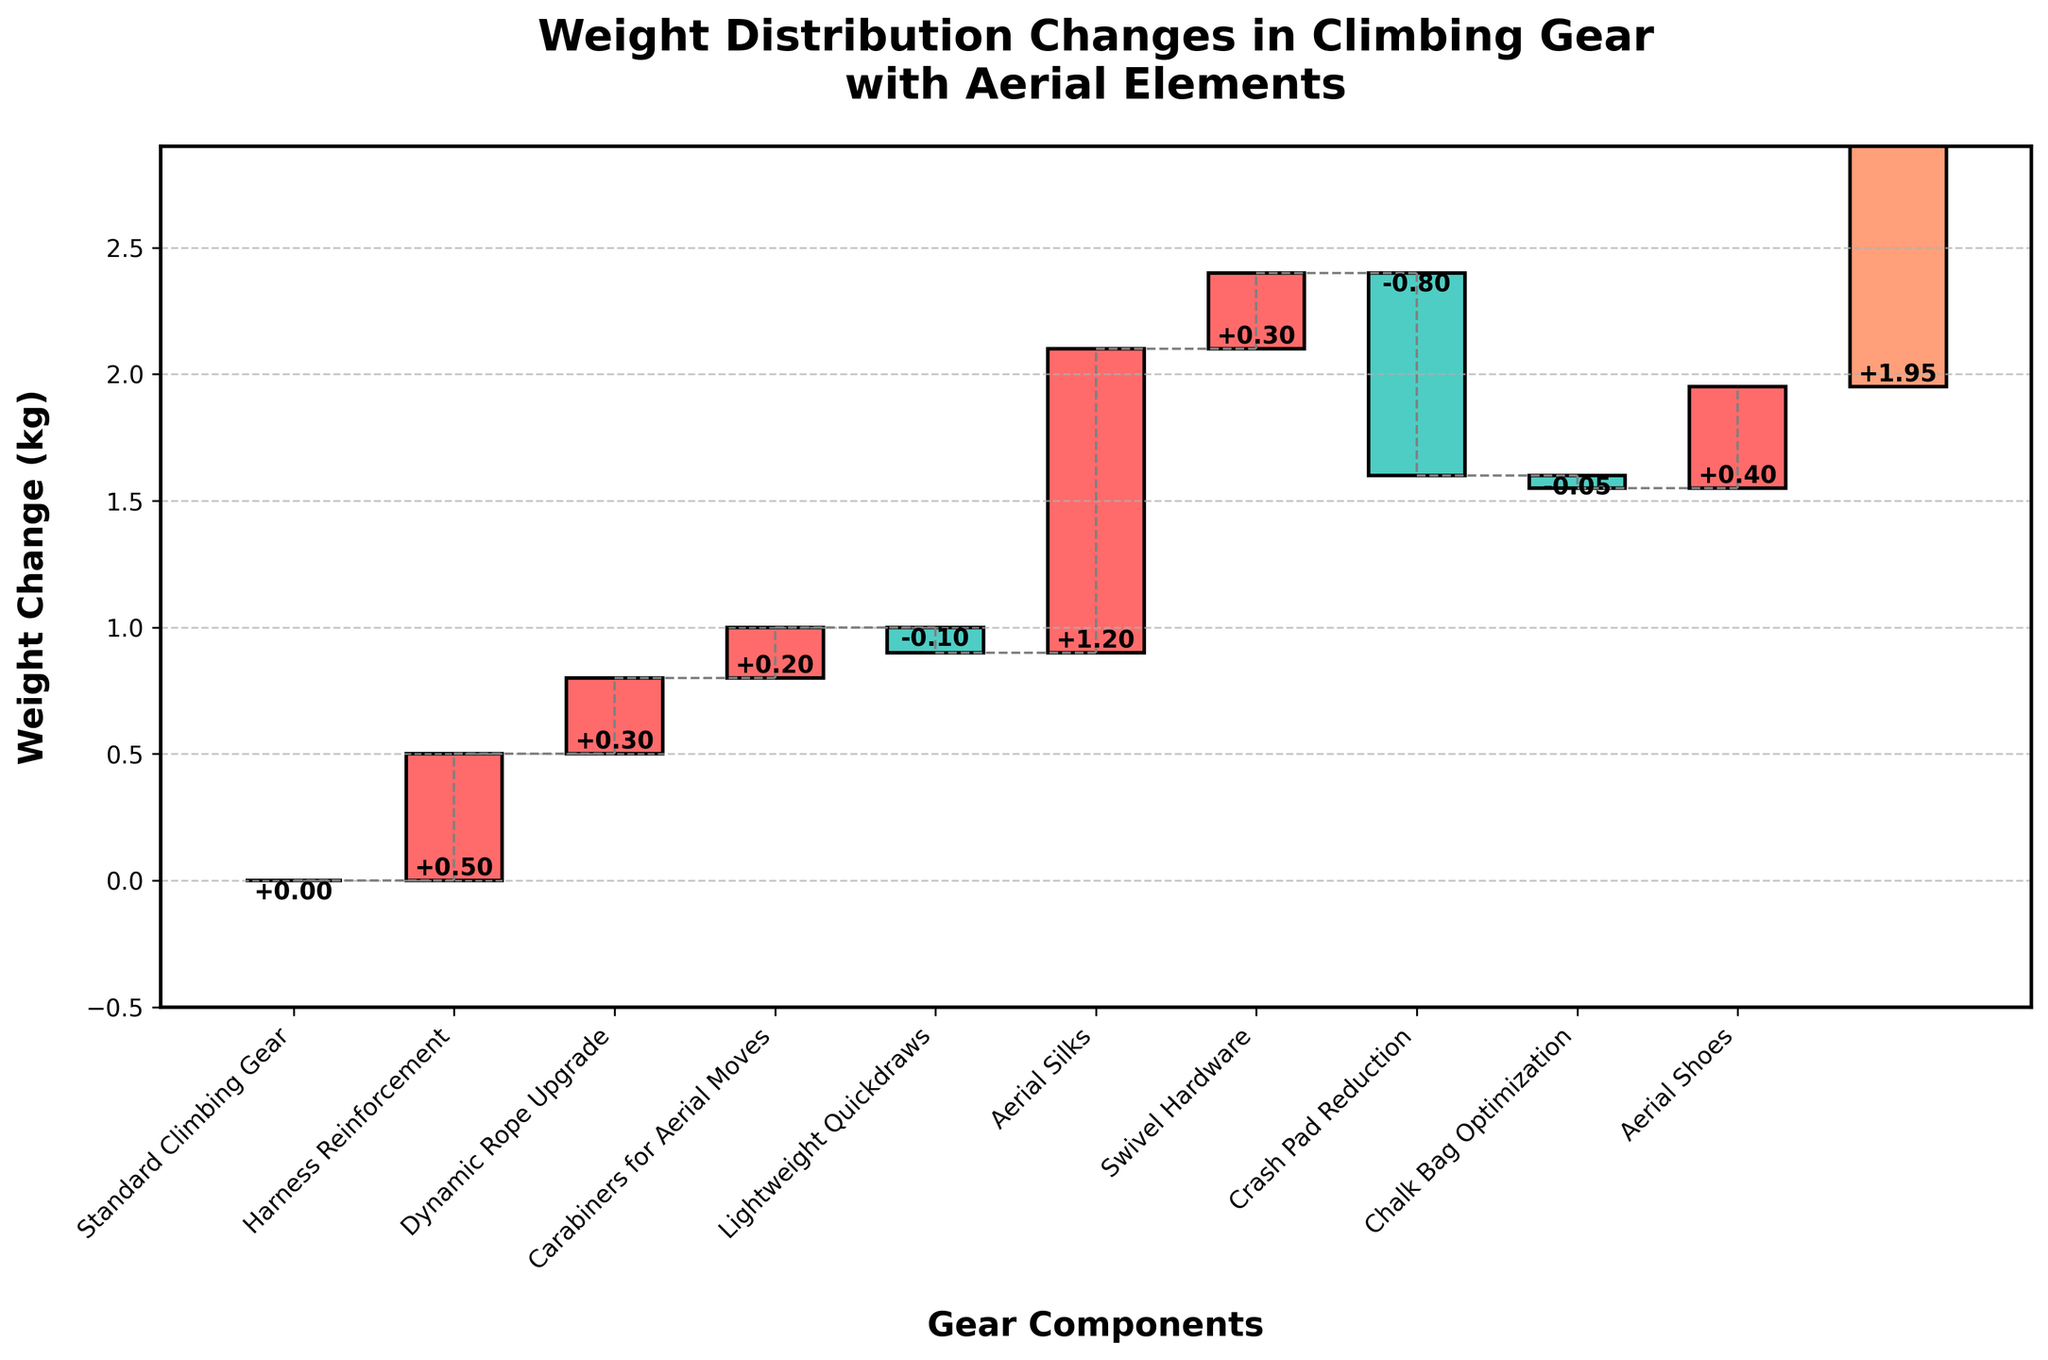what is the title of the chart? The title of the chart is positioned at the top and is styled in bold, larger font for prominence. The title reads "Weight Distribution Changes in Climbing Gear with Aerial Elements".
Answer: Weight Distribution Changes in Climbing Gear with Aerial Elements Which categories contribute to decreasing the total weight? Categories with negative values contribute to weight decrements. In the chart, these are "Lightweight Quickdraws", "Crash Pad Reduction", and "Chalk Bag Optimization" with values of -0.1, -0.8, and -0.05 respectively.
Answer: Lightweight Quickdraws, Crash Pad Reduction, Chalk Bag Optimization What is the weight change due to the addition of aerial silks? The bar for "Aerial Silks" is labeled with a value of +1.2 kg. This is the amount the aerial silks add to the total weight.
Answer: +1.2 kg How does the weight change from harness reinforcement compare to the fresh weight added by new aerial shoes? "Harness Reinforcement" adds +0.5 kg whereas "Aerial Shoes" add +0.4 kg. Comparing the two, the harness reinforcement increases the weight slightly more than the aerial shoes.
Answer: Harness Reinforcement adds more weight than Aerial Shoes Calculate the cumulative weight change after incorporating the dynamic rope upgrade and carabiners for aerial moves. For cumulative calculations, sum the values step-by-step: start with the dynamic rope upgrade +0.3 kg and then include carabiners for aerial moves +0.2 kg. The cumulative sum is 0.3 + 0.2 = 0.5 kg.
Answer: 0.5 kg Which component has the largest single weight increase? Reviewing the bars with positive values, "Aerial Silks" stands out with the highest individual value of +1.2 kg.
Answer: Aerial Silks What is the final total weight change after all components are considered? The chart includes a "Total Weight Change" bar at the end, labeled with a value of +1.95 kg, indicating the overall added weight after considering all components.
Answer: +1.95 kg Identify the component with the smallest weight adjustment and its value. Among all components, the "Chalk Bag Optimization" has the smallest adjustment with a value of -0.05 kg.
Answer: Chalk Bag Optimization, -0.05 kg What's the net weight change contributed by hardware upgrades and their optimization? Summing up the weights for "Harness Reinforcement" (+0.5 kg), "Dynamic Rope Upgrade" (+0.3 kg), "Carabiners for Aerial Moves" (+0.2 kg), "Swivel Hardware" (+0.3 kg), and subtract "Lightweight Quickdraws" (-0.1 kg): 0.5 + 0.3 + 0.2 + 0.3 - 0.1 = 1.2 kg.
Answer: +1.2 kg Which components have exclusively positive contribution to weight change? By examining the chart for positive values, "Harness Reinforcement" (+0.5 kg), "Dynamic Rope Upgrade" (+0.3 kg), "Carabiners for Aerial Moves" (+0.2 kg), "Aerial Silks" (+1.2 kg), "Swivel Hardware" (+0.3 kg), and "Aerial Shoes" (+0.4 kg) all add weight.
Answer: Harness Reinforcement, Dynamic Rope Upgrade, Carabiners for Aerial Moves, Aerial Silks, Swivel Hardware, Aerial Shoes 